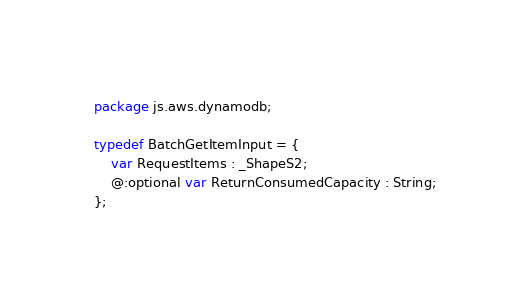<code> <loc_0><loc_0><loc_500><loc_500><_Haxe_>package js.aws.dynamodb;

typedef BatchGetItemInput = {
    var RequestItems : _ShapeS2;
    @:optional var ReturnConsumedCapacity : String;
};
</code> 